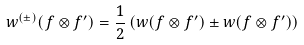<formula> <loc_0><loc_0><loc_500><loc_500>w ^ { ( \pm ) } ( f \otimes f ^ { \prime } ) = \frac { 1 } { 2 } \left ( w ( f \otimes f ^ { \prime } ) \pm w ( f \otimes f ^ { \prime } ) \right )</formula> 